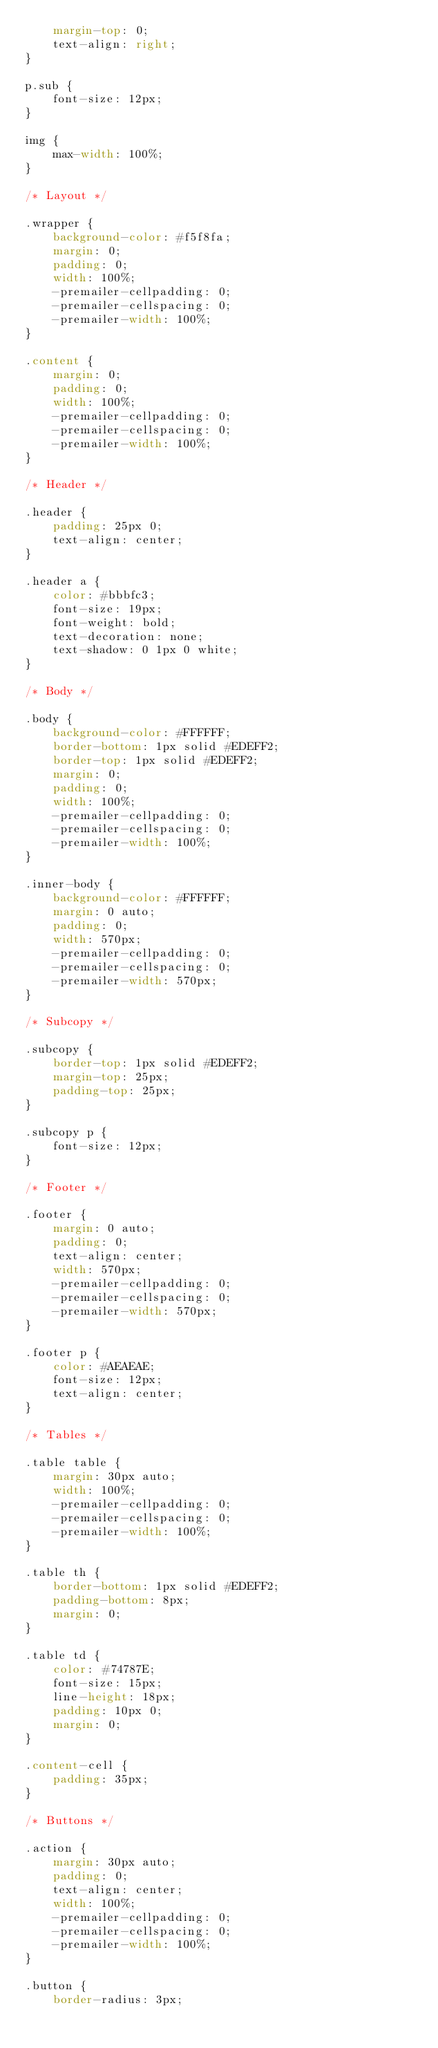Convert code to text. <code><loc_0><loc_0><loc_500><loc_500><_CSS_>    margin-top: 0;
    text-align: right;
}

p.sub {
    font-size: 12px;
}

img {
    max-width: 100%;
}

/* Layout */

.wrapper {
    background-color: #f5f8fa;
    margin: 0;
    padding: 0;
    width: 100%;
    -premailer-cellpadding: 0;
    -premailer-cellspacing: 0;
    -premailer-width: 100%;
}

.content {
    margin: 0;
    padding: 0;
    width: 100%;
    -premailer-cellpadding: 0;
    -premailer-cellspacing: 0;
    -premailer-width: 100%;
}

/* Header */

.header {
    padding: 25px 0;
    text-align: center;
}

.header a {
    color: #bbbfc3;
    font-size: 19px;
    font-weight: bold;
    text-decoration: none;
    text-shadow: 0 1px 0 white;
}

/* Body */

.body {
    background-color: #FFFFFF;
    border-bottom: 1px solid #EDEFF2;
    border-top: 1px solid #EDEFF2;
    margin: 0;
    padding: 0;
    width: 100%;
    -premailer-cellpadding: 0;
    -premailer-cellspacing: 0;
    -premailer-width: 100%;
}

.inner-body {
    background-color: #FFFFFF;
    margin: 0 auto;
    padding: 0;
    width: 570px;
    -premailer-cellpadding: 0;
    -premailer-cellspacing: 0;
    -premailer-width: 570px;
}

/* Subcopy */

.subcopy {
    border-top: 1px solid #EDEFF2;
    margin-top: 25px;
    padding-top: 25px;
}

.subcopy p {
    font-size: 12px;
}

/* Footer */

.footer {
    margin: 0 auto;
    padding: 0;
    text-align: center;
    width: 570px;
    -premailer-cellpadding: 0;
    -premailer-cellspacing: 0;
    -premailer-width: 570px;
}

.footer p {
    color: #AEAEAE;
    font-size: 12px;
    text-align: center;
}

/* Tables */

.table table {
    margin: 30px auto;
    width: 100%;
    -premailer-cellpadding: 0;
    -premailer-cellspacing: 0;
    -premailer-width: 100%;
}

.table th {
    border-bottom: 1px solid #EDEFF2;
    padding-bottom: 8px;
    margin: 0;
}

.table td {
    color: #74787E;
    font-size: 15px;
    line-height: 18px;
    padding: 10px 0;
    margin: 0;
}

.content-cell {
    padding: 35px;
}

/* Buttons */

.action {
    margin: 30px auto;
    padding: 0;
    text-align: center;
    width: 100%;
    -premailer-cellpadding: 0;
    -premailer-cellspacing: 0;
    -premailer-width: 100%;
}

.button {
    border-radius: 3px;</code> 